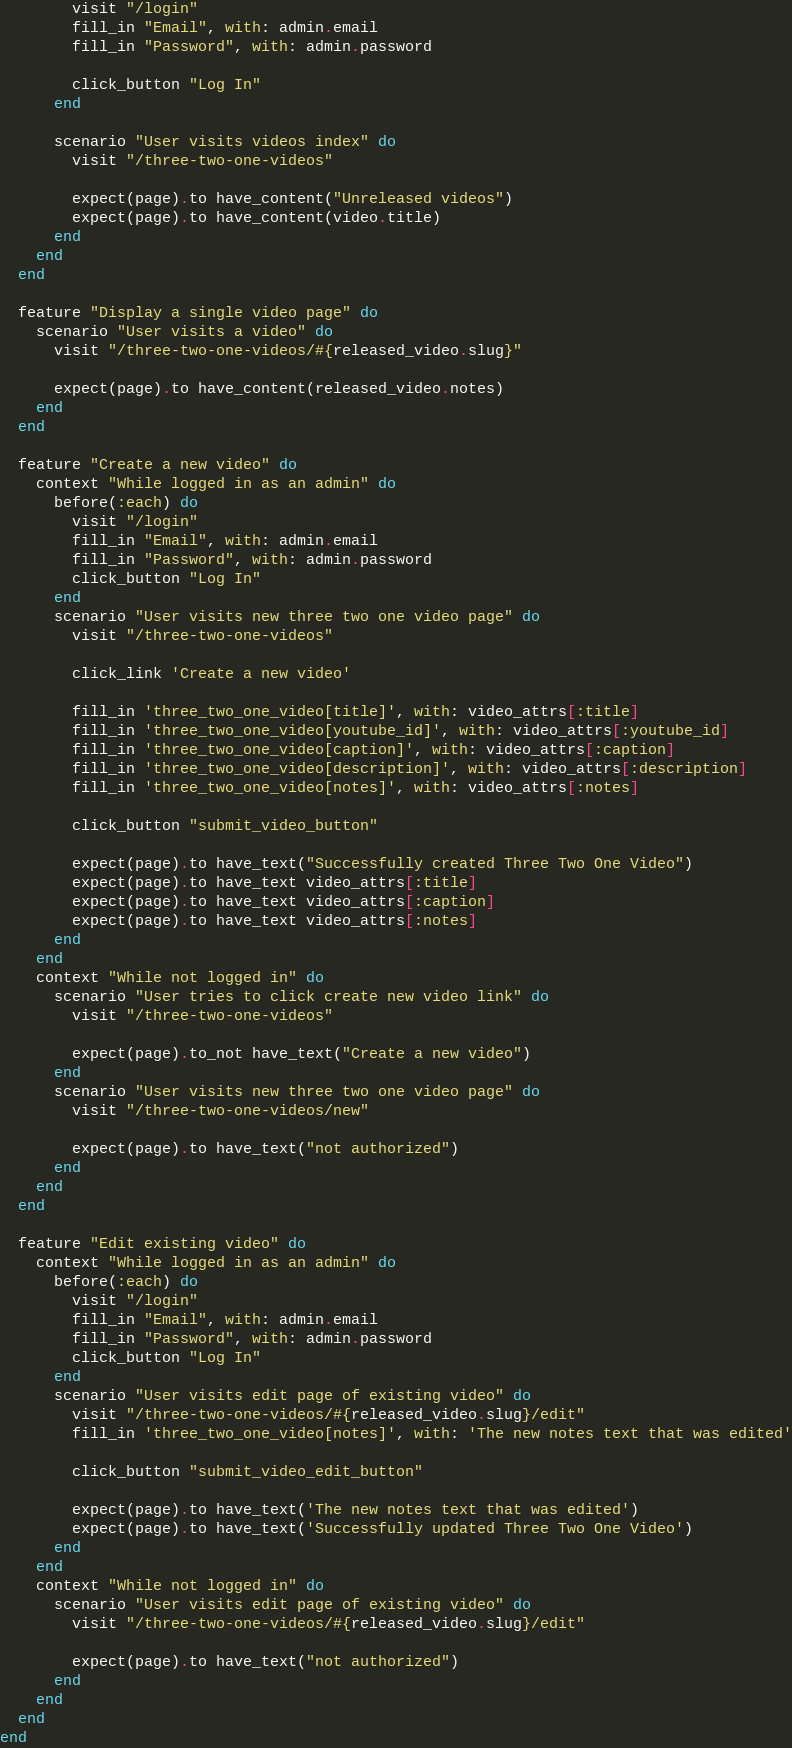Convert code to text. <code><loc_0><loc_0><loc_500><loc_500><_Ruby_>        visit "/login"
        fill_in "Email", with: admin.email
        fill_in "Password", with: admin.password

        click_button "Log In"
      end

      scenario "User visits videos index" do
        visit "/three-two-one-videos"

        expect(page).to have_content("Unreleased videos")
        expect(page).to have_content(video.title)
      end
    end
  end

  feature "Display a single video page" do
    scenario "User visits a video" do
      visit "/three-two-one-videos/#{released_video.slug}"

      expect(page).to have_content(released_video.notes)
    end
  end

  feature "Create a new video" do
    context "While logged in as an admin" do
      before(:each) do
        visit "/login"
        fill_in "Email", with: admin.email
        fill_in "Password", with: admin.password
        click_button "Log In"
      end
      scenario "User visits new three two one video page" do
        visit "/three-two-one-videos"

        click_link 'Create a new video'

        fill_in 'three_two_one_video[title]', with: video_attrs[:title]
        fill_in 'three_two_one_video[youtube_id]', with: video_attrs[:youtube_id]
        fill_in 'three_two_one_video[caption]', with: video_attrs[:caption]
        fill_in 'three_two_one_video[description]', with: video_attrs[:description]
        fill_in 'three_two_one_video[notes]', with: video_attrs[:notes]

        click_button "submit_video_button"

        expect(page).to have_text("Successfully created Three Two One Video")
        expect(page).to have_text video_attrs[:title]
        expect(page).to have_text video_attrs[:caption]
        expect(page).to have_text video_attrs[:notes]
      end
    end
    context "While not logged in" do
      scenario "User tries to click create new video link" do
        visit "/three-two-one-videos"

        expect(page).to_not have_text("Create a new video")
      end
      scenario "User visits new three two one video page" do
        visit "/three-two-one-videos/new"

        expect(page).to have_text("not authorized")
      end
    end
  end

  feature "Edit existing video" do
    context "While logged in as an admin" do
      before(:each) do
        visit "/login"
        fill_in "Email", with: admin.email
        fill_in "Password", with: admin.password
        click_button "Log In"
      end
      scenario "User visits edit page of existing video" do
        visit "/three-two-one-videos/#{released_video.slug}/edit"
        fill_in 'three_two_one_video[notes]', with: 'The new notes text that was edited'

        click_button "submit_video_edit_button"

        expect(page).to have_text('The new notes text that was edited')
        expect(page).to have_text('Successfully updated Three Two One Video')
      end
    end
    context "While not logged in" do
      scenario "User visits edit page of existing video" do
        visit "/three-two-one-videos/#{released_video.slug}/edit"

        expect(page).to have_text("not authorized")
      end
    end
  end
end
</code> 